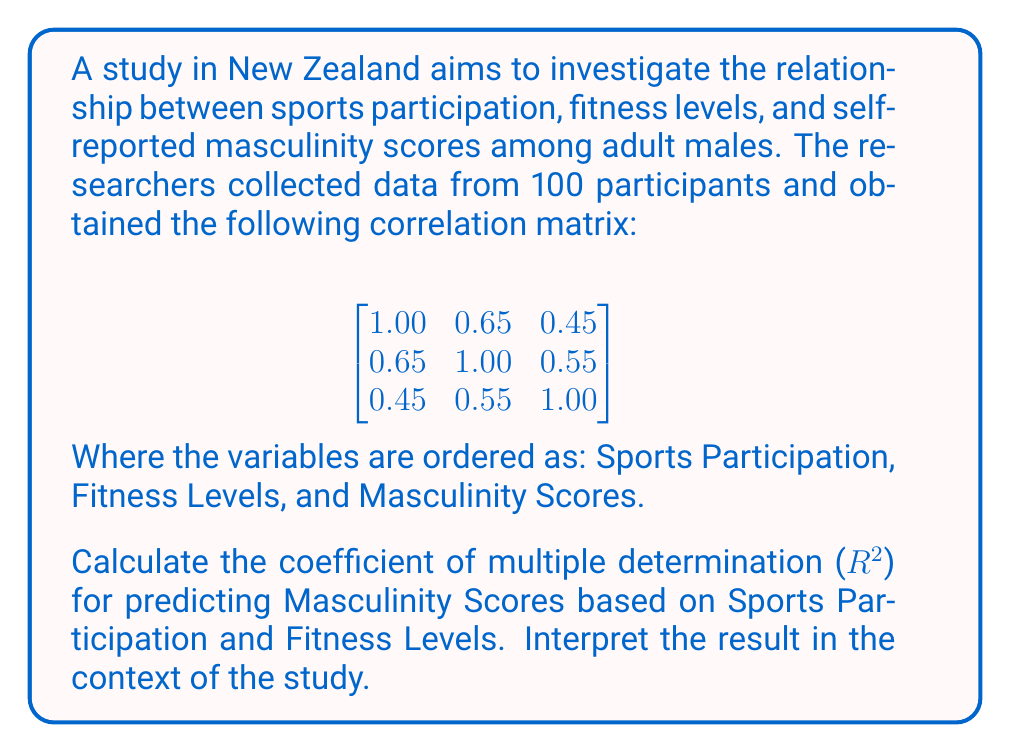Help me with this question. To solve this problem, we'll follow these steps:

1. Identify the correlation coefficients:
   $r_{12} = 0.65$ (Sports Participation and Fitness Levels)
   $r_{13} = 0.45$ (Sports Participation and Masculinity Scores)
   $r_{23} = 0.55$ (Fitness Levels and Masculinity Scores)

2. Calculate the coefficient of multiple determination ($R^2$) using the formula:

   $$R^2 = \frac{r_{13}^2 + r_{23}^2 - 2r_{12}r_{13}r_{23}}{1 - r_{12}^2}$$

3. Substitute the values into the formula:

   $$R^2 = \frac{(0.45)^2 + (0.55)^2 - 2(0.65)(0.45)(0.55)}{1 - (0.65)^2}$$

4. Solve the equation:

   $$R^2 = \frac{0.2025 + 0.3025 - 0.32175}{1 - 0.4225}$$
   
   $$R^2 = \frac{0.18325}{0.5775}$$
   
   $$R^2 = 0.3173$$

5. Interpret the result:
   The coefficient of multiple determination ($R^2$) is approximately 0.3173 or 31.73%. This means that about 31.73% of the variance in Masculinity Scores can be explained by the combined effects of Sports Participation and Fitness Levels.

   In the context of the study, this suggests a moderate relationship between the predictor variables (Sports Participation and Fitness Levels) and the outcome variable (Masculinity Scores). However, it also indicates that a significant portion (about 68.27%) of the variance in Masculinity Scores is not explained by these two factors alone, suggesting that other variables not included in this analysis may play important roles in determining self-reported masculinity scores among New Zealand men.
Answer: $R^2 = 0.3173$ or 31.73% 